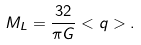Convert formula to latex. <formula><loc_0><loc_0><loc_500><loc_500>M _ { L } = \frac { 3 2 } { \pi G } < q > .</formula> 